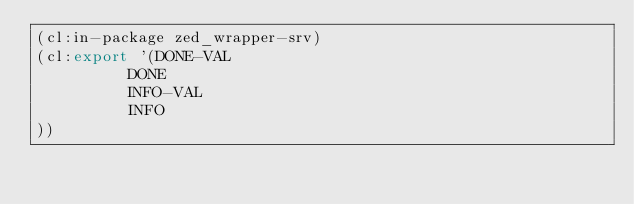<code> <loc_0><loc_0><loc_500><loc_500><_Lisp_>(cl:in-package zed_wrapper-srv)
(cl:export '(DONE-VAL
          DONE
          INFO-VAL
          INFO
))</code> 